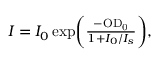Convert formula to latex. <formula><loc_0><loc_0><loc_500><loc_500>\begin{array} { r } { { I } = { I _ { 0 } } \, e x p \left ( \frac { - { { O D } _ { 0 } } } { 1 + { I _ { 0 } } / { I _ { s } } } \right ) , } \end{array}</formula> 